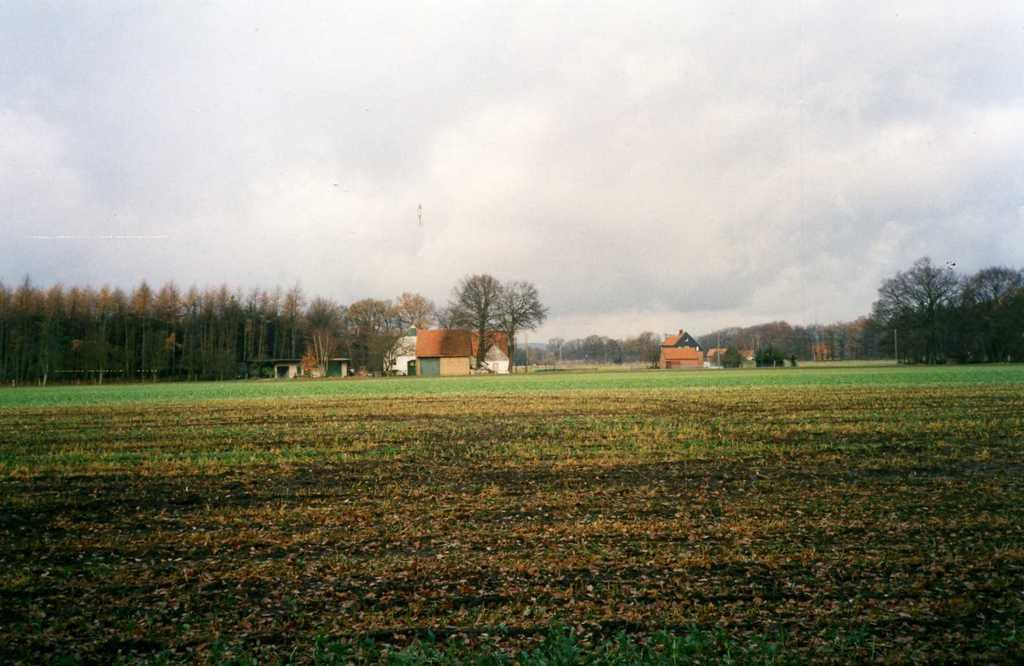What can be seen at the bottom of the image? The ground is visible in the image. What type of structures can be seen in the background of the image? There are houses in the background of the image. What is the color of the houses in the image? The houses are brown in color. What type of vegetation is present in the background of the image? There are many trees in the background of the image. What is one feature of the sky visible in the background of the image? There is a cloud visible in the background of the image. What else can be seen in the sky in the background of the image? The sky is visible in the background of the image. What type of humor can be seen in the image? There is no humor present in the image; it is a landscape featuring houses, trees, and a cloudy sky. What is the hammer being used for in the image? There is no hammer present in the image. 